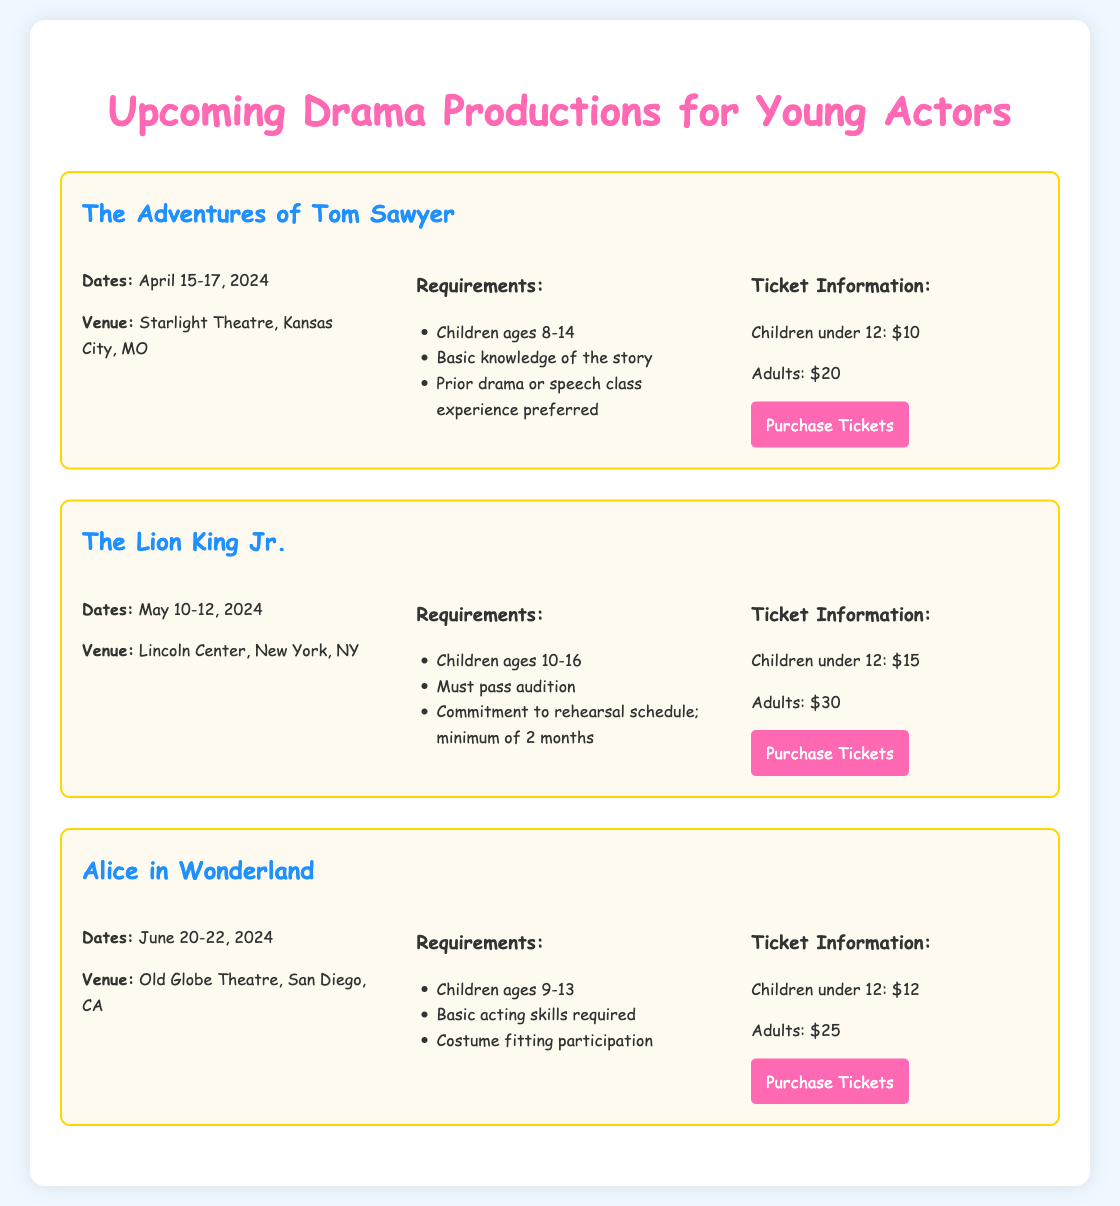What are the dates for "The Adventures of Tom Sawyer"? The specific dates for the production are mentioned in the document which states from April 15-17, 2024.
Answer: April 15-17, 2024 Where is "The Lion King Jr." being held? The venue for "The Lion King Jr." production is given in the document as Lincoln Center, New York, NY.
Answer: Lincoln Center, New York, NY What is the age requirement for "Alice in Wonderland"? The requirements for participation include the age range, specifically for "Alice in Wonderland," which is stated as children ages 9-13.
Answer: Children ages 9-13 How much do adult tickets cost for "The Adventures of Tom Sawyer"? The document lists ticket prices for adults, specifically $20 for "The Adventures of Tom Sawyer."
Answer: $20 What is the minimum audition commitment for "The Lion King Jr."? The document specifies a minimum commitment duration related to rehearsal, which is a minimum of 2 months for "The Lion King Jr."
Answer: Minimum of 2 months Which production requires costume fitting participation? The specific production related to costume fitting participation is mentioned in the requirements section of the document for "Alice in Wonderland."
Answer: Alice in Wonderland How much is a child ticket for "Alice in Wonderland"? The ticket price for children under 12 for "Alice in Wonderland" is clearly stated in the document as $12.
Answer: $12 What is the ticket purchasing link for "The Lion King Jr."? The document provides a specific link for purchasing tickets for "The Lion King Jr.," which directs to Lincoln Center's website.
Answer: https://www.lincolncenter.org/lion-king-jr-tickets What is the color of the title font used in the document? The title's color is defined in the document's style section, specifically a bright color.
Answer: #ff69b4 